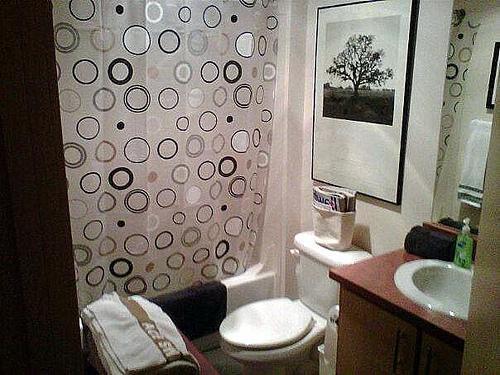How many pictures are hanging above the toilet?
Give a very brief answer. 1. 